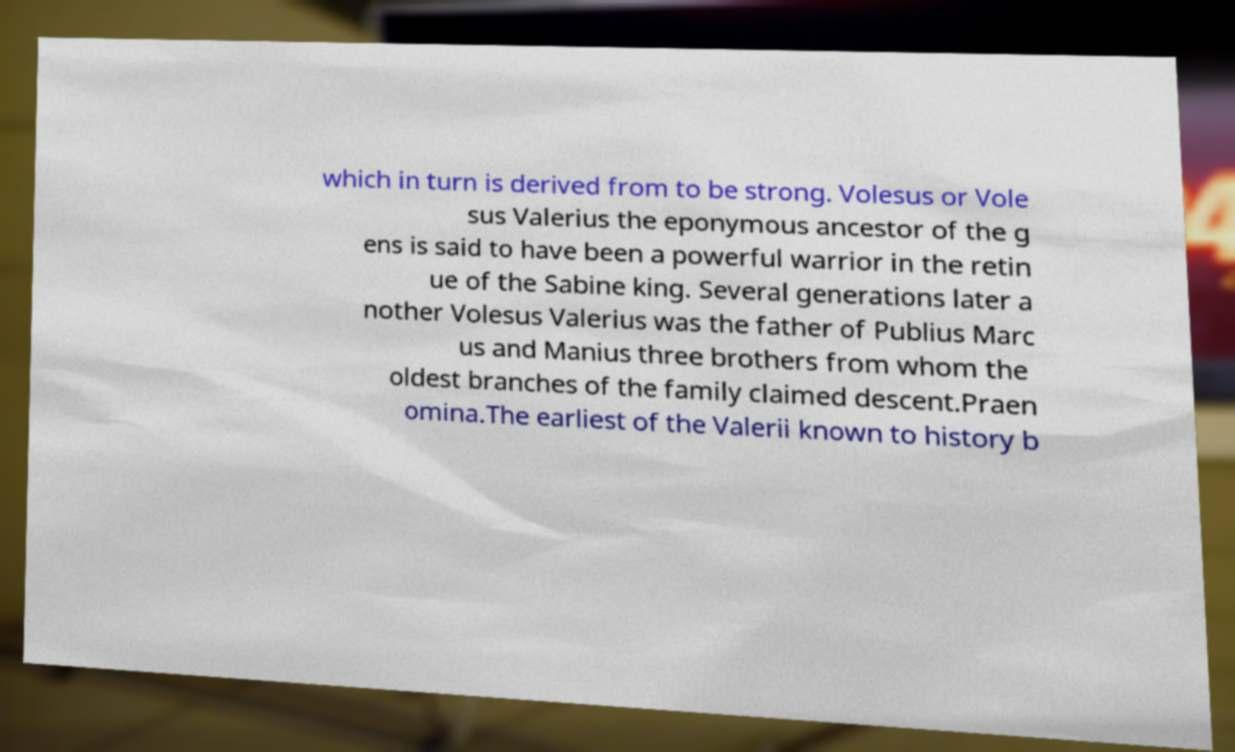Please read and relay the text visible in this image. What does it say? which in turn is derived from to be strong. Volesus or Vole sus Valerius the eponymous ancestor of the g ens is said to have been a powerful warrior in the retin ue of the Sabine king. Several generations later a nother Volesus Valerius was the father of Publius Marc us and Manius three brothers from whom the oldest branches of the family claimed descent.Praen omina.The earliest of the Valerii known to history b 